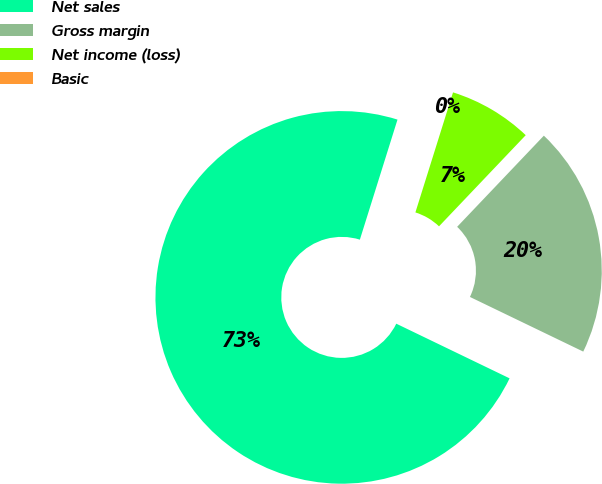Convert chart. <chart><loc_0><loc_0><loc_500><loc_500><pie_chart><fcel>Net sales<fcel>Gross margin<fcel>Net income (loss)<fcel>Basic<nl><fcel>72.68%<fcel>20.05%<fcel>7.27%<fcel>0.0%<nl></chart> 